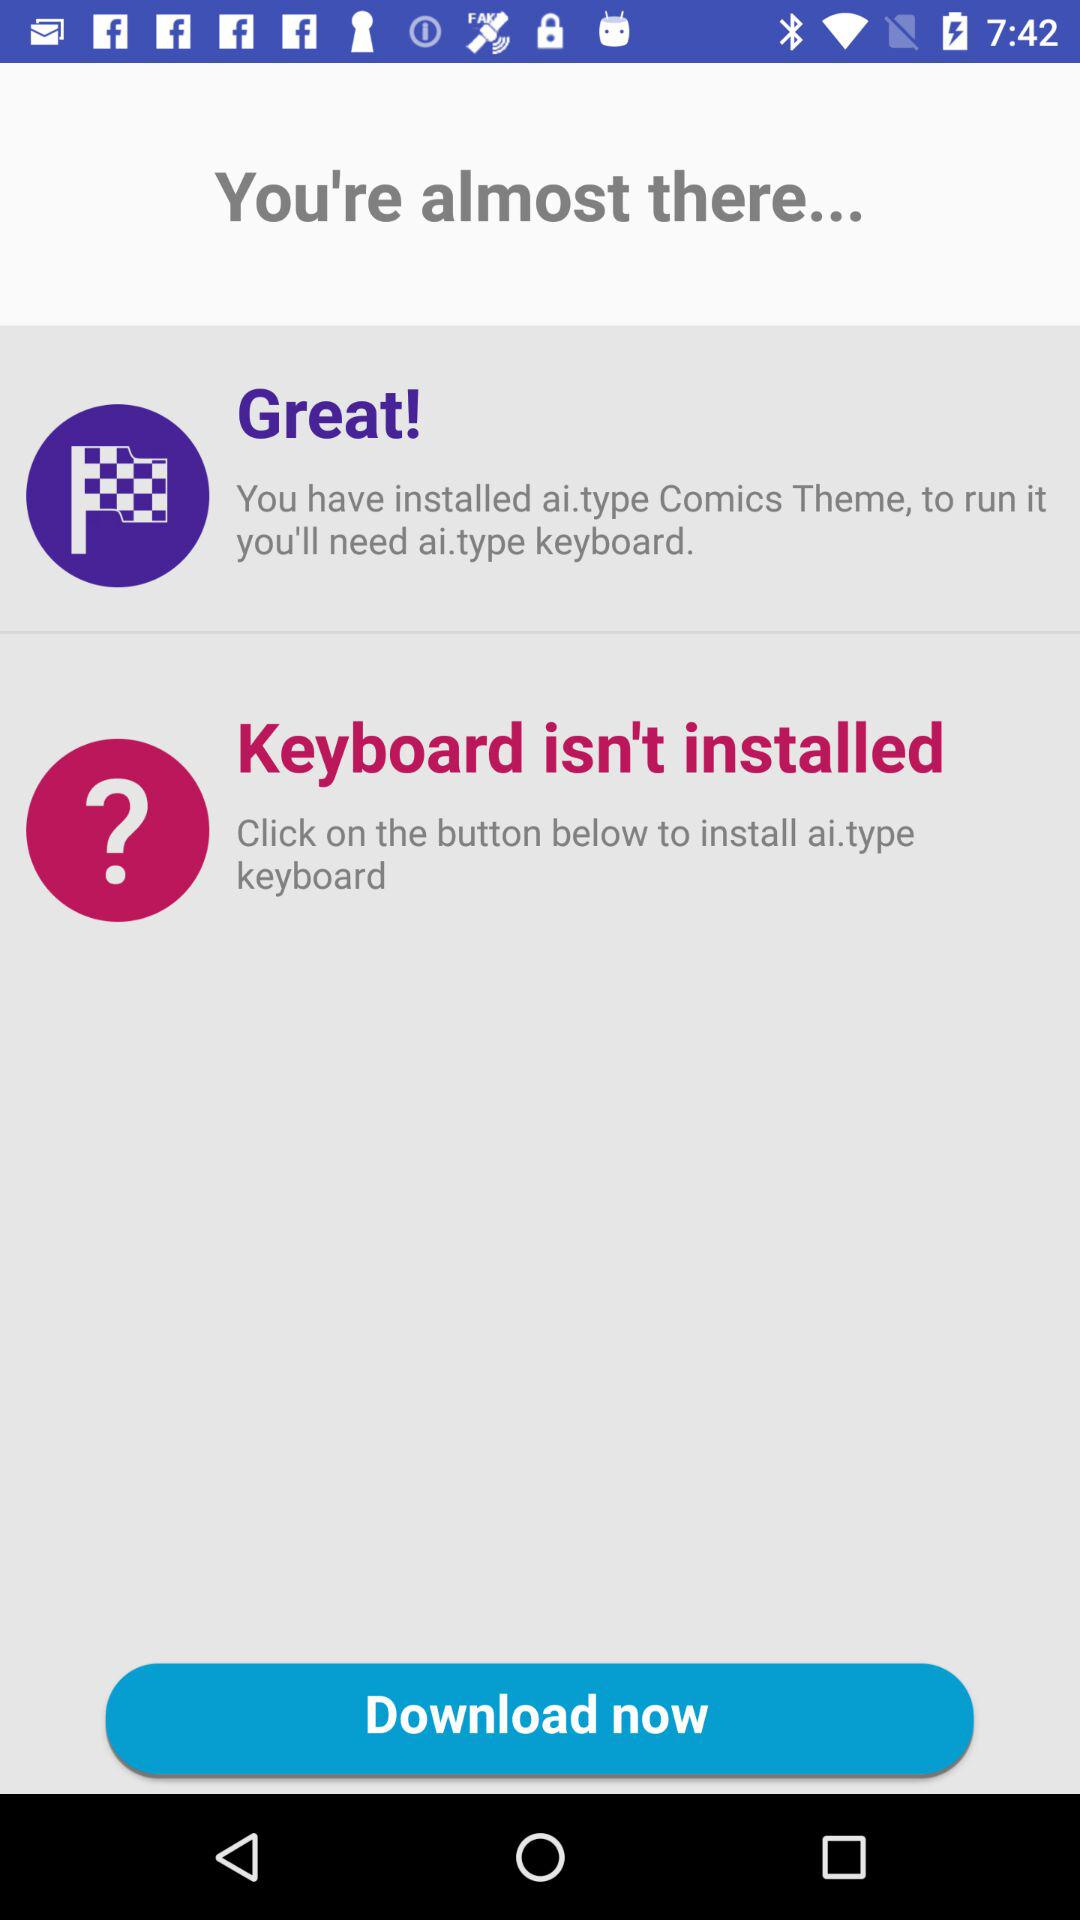What should I install to use the ai.type comics theme? You should install a keyboard to use the ai.type comics theme. 